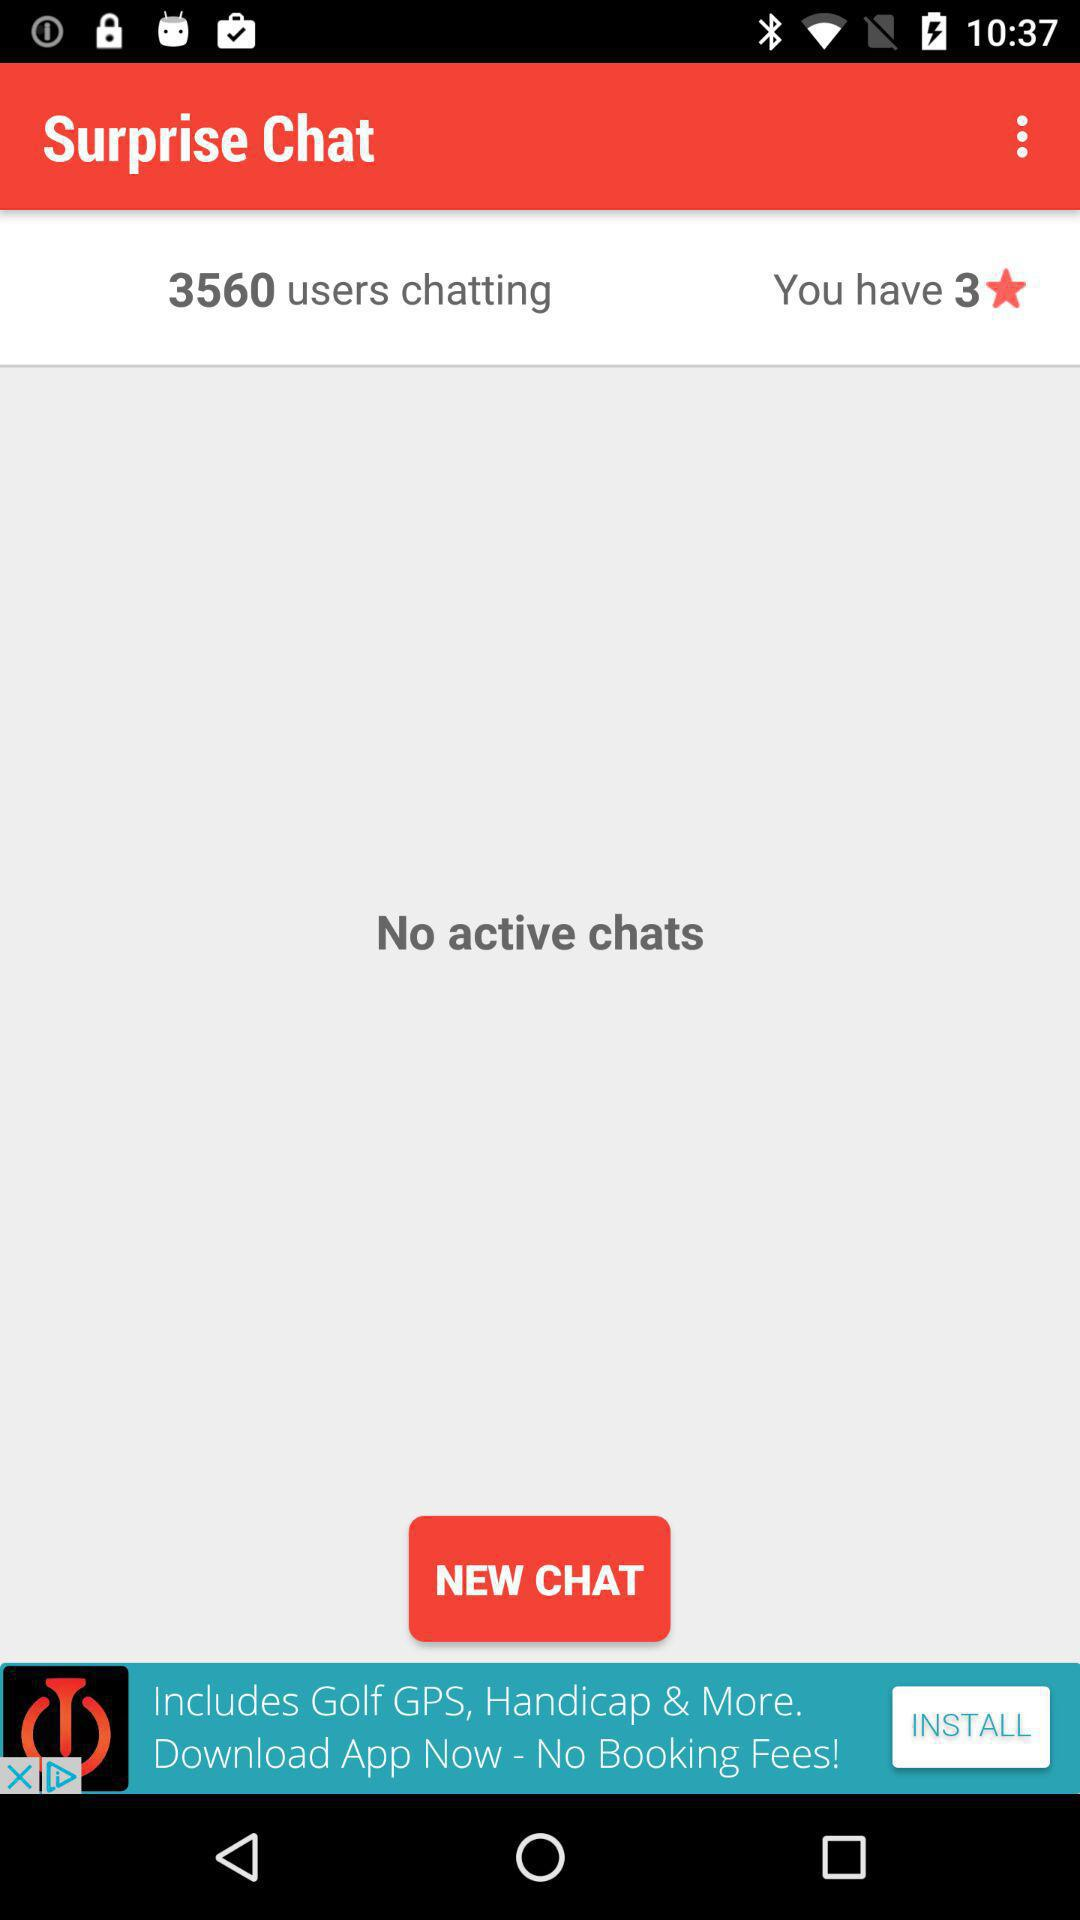How many stars are there? There are 3 stars. 